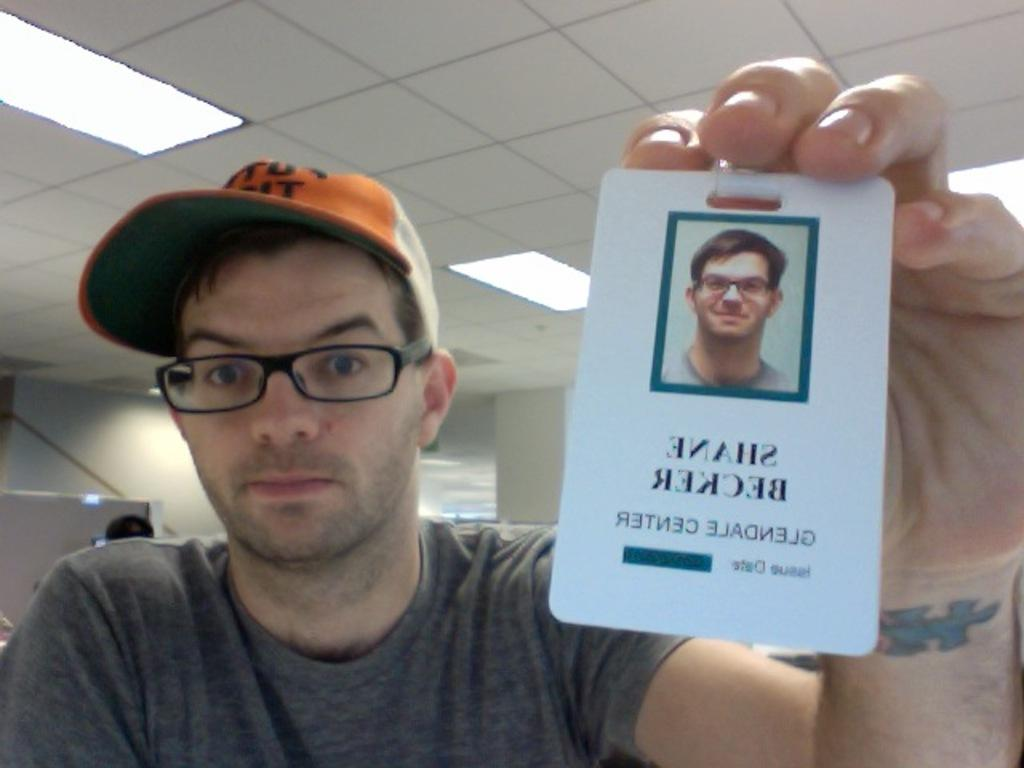What can be seen in the image? There is a person in the image. Can you describe the person's appearance? The person is wearing spectacles and a cap. What is the person holding in the image? The person is holding a card. What is visible on the ceiling in the image? There are lights on the ceiling. Where is the ceiling located in the image? The ceiling is at the top of the image. What type of popcorn is being served to the horse in the image? There is no horse or popcorn present in the image. 